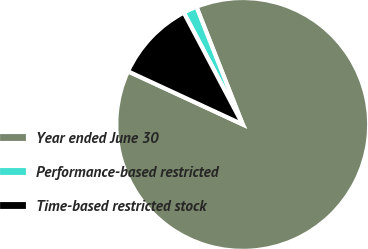Convert chart. <chart><loc_0><loc_0><loc_500><loc_500><pie_chart><fcel>Year ended June 30<fcel>Performance-based restricted<fcel>Time-based restricted stock<nl><fcel>87.87%<fcel>1.76%<fcel>10.37%<nl></chart> 